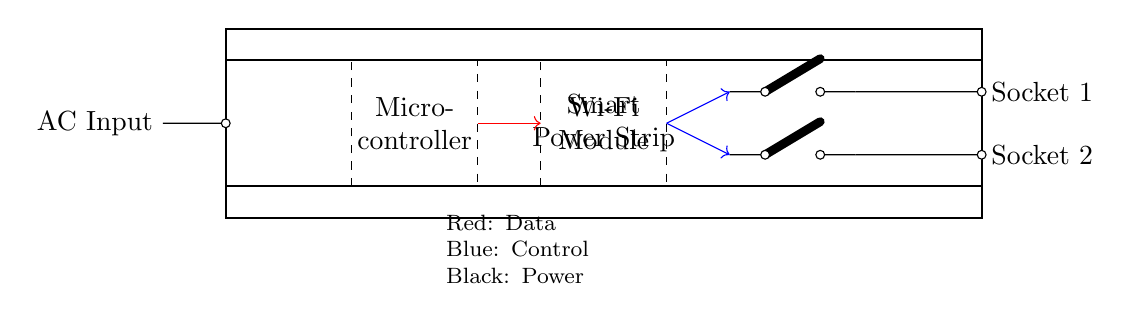What is the main purpose of this circuit? The main purpose of this circuit is to provide remote monitoring and control of multiple devices via a smart power strip. The presence of a microcontroller and Wi-Fi module indicates that it can be managed through a network.
Answer: remote monitoring and control How many output sockets are there? The circuit shows two output sockets labeled Socket 1 and Socket 2, indicating that the power strip can connect to two devices simultaneously.
Answer: two What does the red arrow represent? In the circuit, the red arrow indicates the data connection between the microcontroller and the Wi-Fi module, highlighting the communication for control and monitoring purposes.
Answer: data connection Which component is used for controlling the power to the sockets? The circuit contains relay modules, which are typically used to control the power supply to connected devices by acting as switches for each socket based on commands from the microcontroller.
Answer: relay modules What type of connection is depicted between the Wi-Fi module and the relay modules? The blue arrows represent control connections; this indicates that the Wi-Fi module sends control signals to the relay modules, which in turn determine the power state of each socket.
Answer: control connection What is the voltage supply indicated in the circuit? The thick black lines at the top and bottom signify the AC voltage supply for the circuit, which is common for power strips generally supplied with standard mains voltage.
Answer: AC voltage What type of switches are implemented for the sockets? The circuit diagram symbolizes the use of cute open switches for controlling the power supply to each socket, allowing users to turn devices on or off remotely.
Answer: cute open switches 